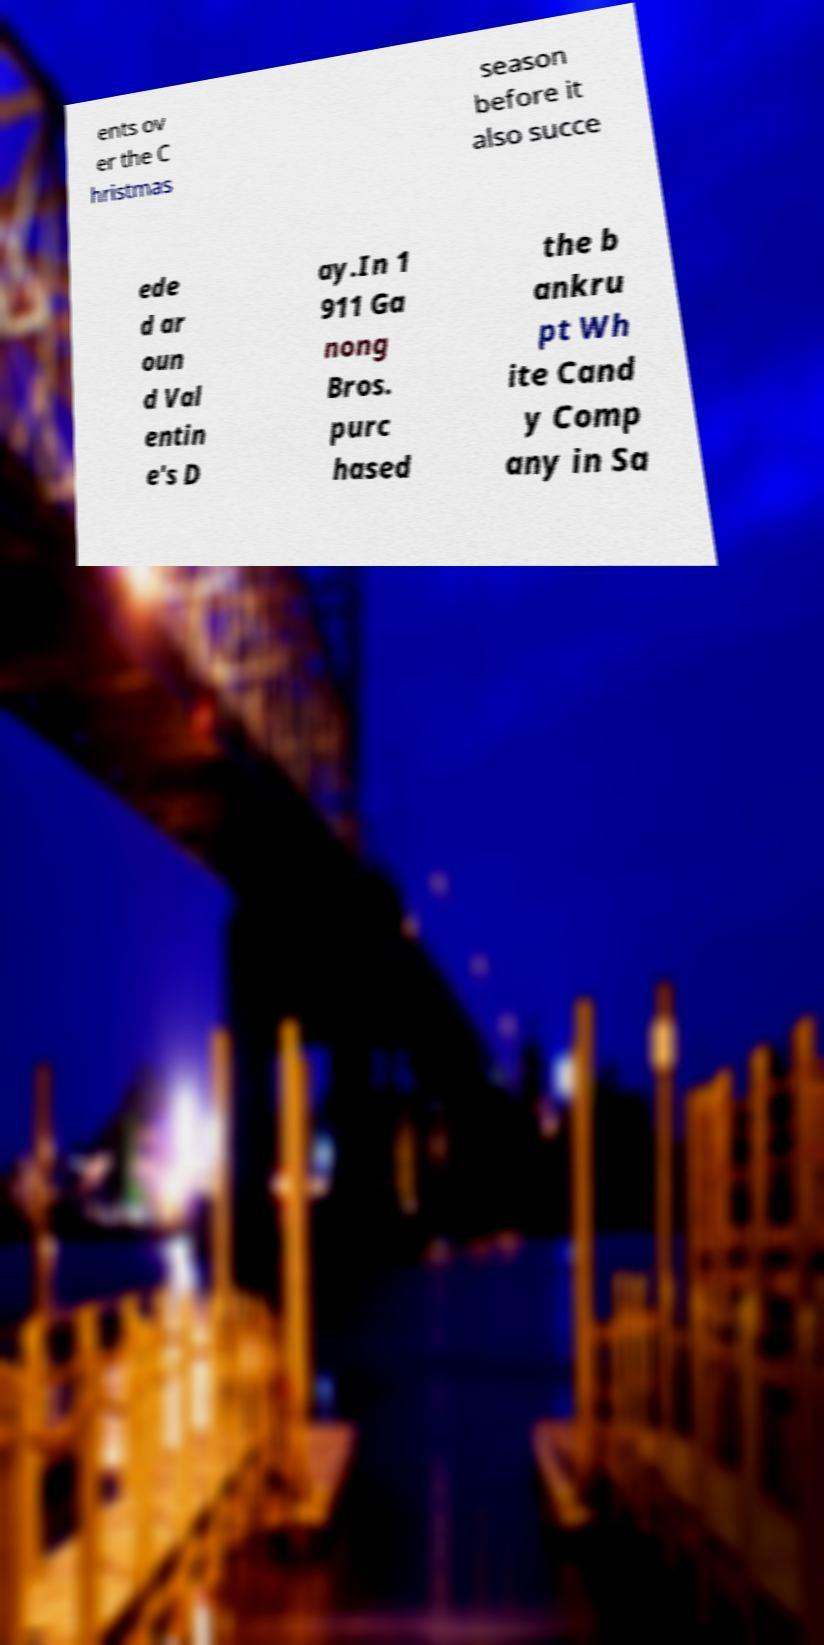I need the written content from this picture converted into text. Can you do that? ents ov er the C hristmas season before it also succe ede d ar oun d Val entin e's D ay.In 1 911 Ga nong Bros. purc hased the b ankru pt Wh ite Cand y Comp any in Sa 